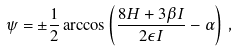<formula> <loc_0><loc_0><loc_500><loc_500>\psi = \pm \frac { 1 } { 2 } \arccos \left ( \frac { 8 H + 3 \beta I } { 2 \epsilon I } - \alpha \right ) \, ,</formula> 